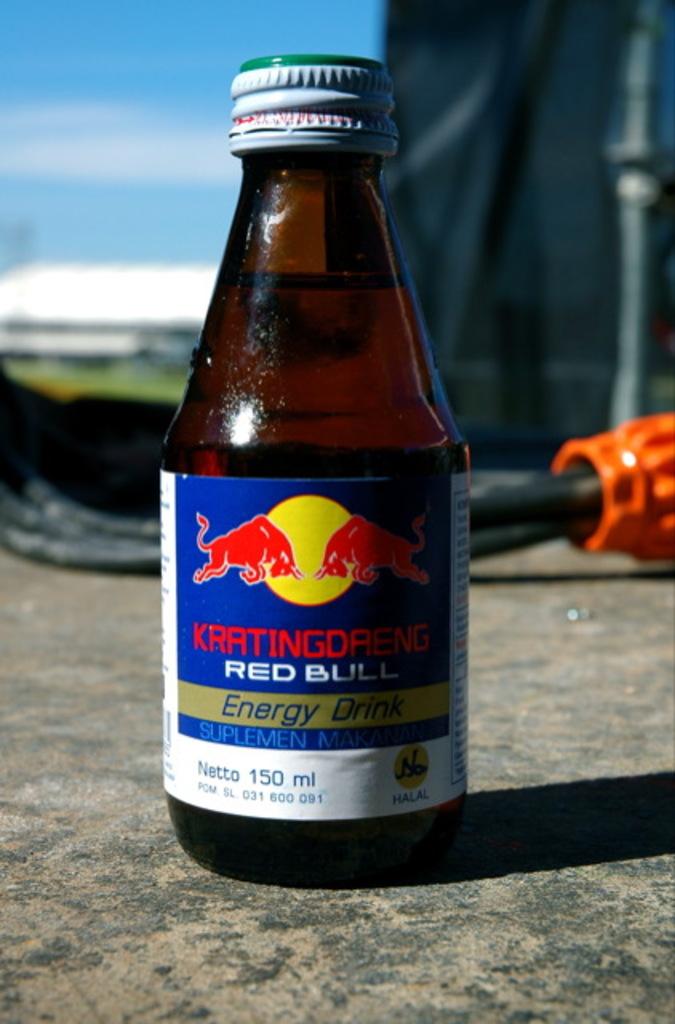What type of drink is red bull?
Provide a short and direct response. Energy drink. 